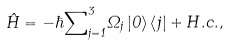Convert formula to latex. <formula><loc_0><loc_0><loc_500><loc_500>\hat { H } = - \hbar { \sum } _ { j = 1 } ^ { 3 } \Omega _ { j } \left | 0 \right \rangle \left \langle j \right | + H . c . ,</formula> 